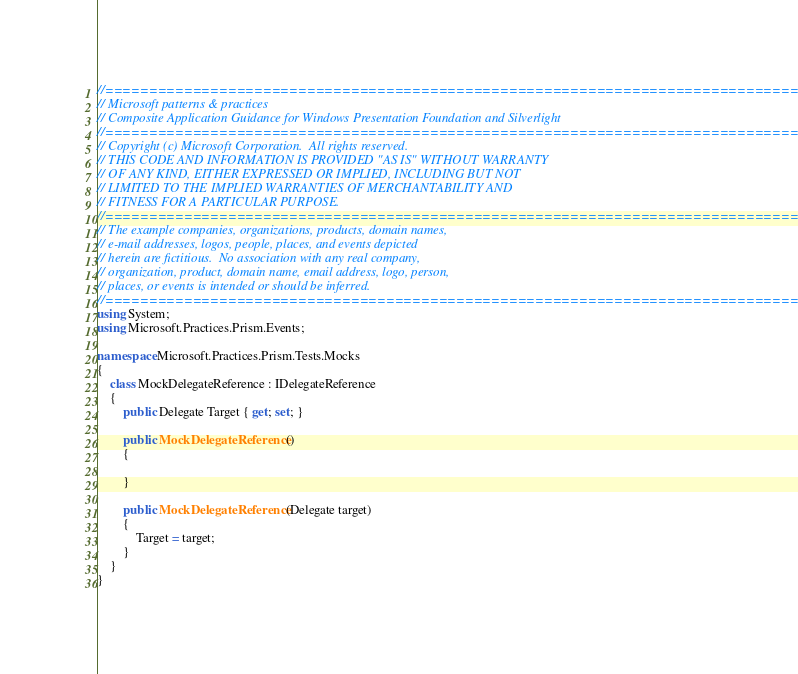Convert code to text. <code><loc_0><loc_0><loc_500><loc_500><_C#_>//===================================================================================
// Microsoft patterns & practices
// Composite Application Guidance for Windows Presentation Foundation and Silverlight
//===================================================================================
// Copyright (c) Microsoft Corporation.  All rights reserved.
// THIS CODE AND INFORMATION IS PROVIDED "AS IS" WITHOUT WARRANTY
// OF ANY KIND, EITHER EXPRESSED OR IMPLIED, INCLUDING BUT NOT
// LIMITED TO THE IMPLIED WARRANTIES OF MERCHANTABILITY AND
// FITNESS FOR A PARTICULAR PURPOSE.
//===================================================================================
// The example companies, organizations, products, domain names,
// e-mail addresses, logos, people, places, and events depicted
// herein are fictitious.  No association with any real company,
// organization, product, domain name, email address, logo, person,
// places, or events is intended or should be inferred.
//===================================================================================
using System;
using Microsoft.Practices.Prism.Events;

namespace Microsoft.Practices.Prism.Tests.Mocks
{
    class MockDelegateReference : IDelegateReference
    {
        public Delegate Target { get; set; }

        public MockDelegateReference()
        {

        }

        public MockDelegateReference(Delegate target)
        {
            Target = target;
        }
    }
}</code> 